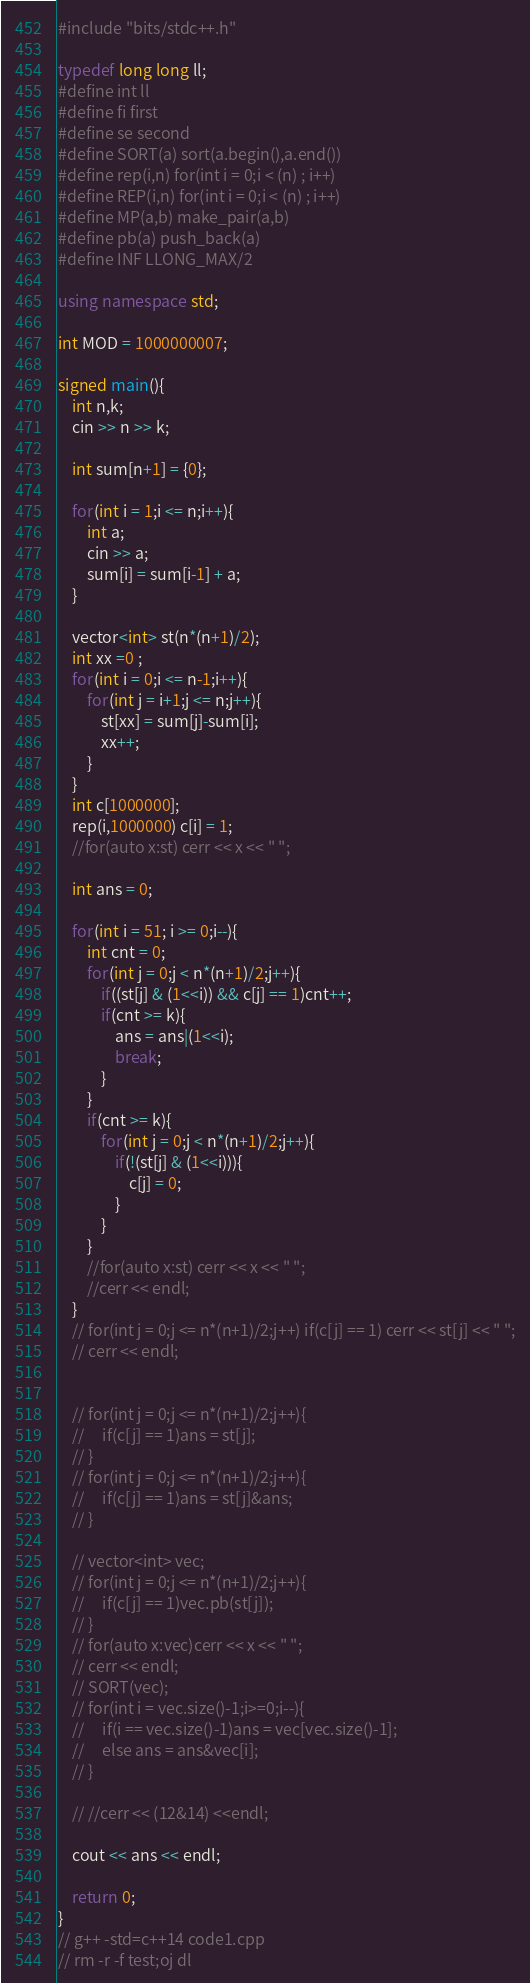<code> <loc_0><loc_0><loc_500><loc_500><_C++_>#include "bits/stdc++.h"
 
typedef long long ll;
#define int ll
#define fi first
#define se second
#define SORT(a) sort(a.begin(),a.end())
#define rep(i,n) for(int i = 0;i < (n) ; i++) 
#define REP(i,n) for(int i = 0;i < (n) ; i++) 
#define MP(a,b) make_pair(a,b)
#define pb(a) push_back(a)
#define INF LLONG_MAX/2

using namespace std;

int MOD = 1000000007;

signed main(){
    int n,k;
    cin >> n >> k;

    int sum[n+1] = {0};

    for(int i = 1;i <= n;i++){
        int a;
        cin >> a;
        sum[i] = sum[i-1] + a;
    }

    vector<int> st(n*(n+1)/2);
    int xx =0 ;
    for(int i = 0;i <= n-1;i++){
        for(int j = i+1;j <= n;j++){
            st[xx] = sum[j]-sum[i];
            xx++;
        }
    }
    int c[1000000];
    rep(i,1000000) c[i] = 1;
    //for(auto x:st) cerr << x << " ";

    int ans = 0;

    for(int i = 51; i >= 0;i--){
        int cnt = 0;
        for(int j = 0;j < n*(n+1)/2;j++){
            if((st[j] & (1<<i)) && c[j] == 1)cnt++;
            if(cnt >= k){
                ans = ans|(1<<i);
                break;
            }
        }
        if(cnt >= k){
            for(int j = 0;j < n*(n+1)/2;j++){
                if(!(st[j] & (1<<i))){
                    c[j] = 0;
                }
            }
        }
        //for(auto x:st) cerr << x << " ";
        //cerr << endl;
    }
    // for(int j = 0;j <= n*(n+1)/2;j++) if(c[j] == 1) cerr << st[j] << " ";
    // cerr << endl;

    
    // for(int j = 0;j <= n*(n+1)/2;j++){
    //     if(c[j] == 1)ans = st[j];
    // }
    // for(int j = 0;j <= n*(n+1)/2;j++){
    //     if(c[j] == 1)ans = st[j]&ans;
    // }

    // vector<int> vec;
    // for(int j = 0;j <= n*(n+1)/2;j++){
    //     if(c[j] == 1)vec.pb(st[j]);
    // }
    // for(auto x:vec)cerr << x << " ";
    // cerr << endl;
    // SORT(vec);
    // for(int i = vec.size()-1;i>=0;i--){
    //     if(i == vec.size()-1)ans = vec[vec.size()-1];
    //     else ans = ans&vec[i];
    // }

    // //cerr << (12&14) <<endl;
    
    cout << ans << endl;
    
    return 0;
}
// g++ -std=c++14 code1.cpp
// rm -r -f test;oj dl </code> 